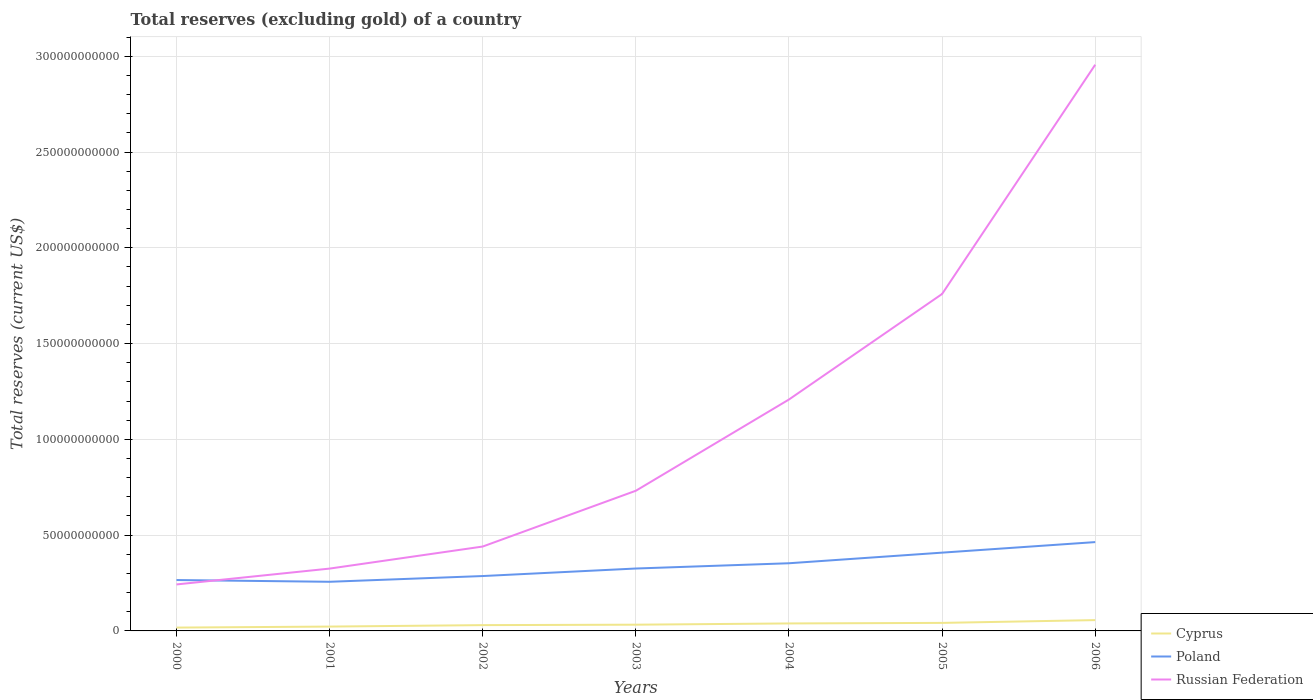Is the number of lines equal to the number of legend labels?
Give a very brief answer. Yes. Across all years, what is the maximum total reserves (excluding gold) in Russian Federation?
Your answer should be very brief. 2.43e+1. In which year was the total reserves (excluding gold) in Cyprus maximum?
Provide a succinct answer. 2000. What is the total total reserves (excluding gold) in Cyprus in the graph?
Provide a succinct answer. -1.92e+09. What is the difference between the highest and the second highest total reserves (excluding gold) in Russian Federation?
Your answer should be very brief. 2.71e+11. How many lines are there?
Make the answer very short. 3. What is the difference between two consecutive major ticks on the Y-axis?
Your answer should be compact. 5.00e+1. Are the values on the major ticks of Y-axis written in scientific E-notation?
Your response must be concise. No. Does the graph contain any zero values?
Provide a short and direct response. No. How many legend labels are there?
Provide a succinct answer. 3. How are the legend labels stacked?
Your response must be concise. Vertical. What is the title of the graph?
Your response must be concise. Total reserves (excluding gold) of a country. Does "Jordan" appear as one of the legend labels in the graph?
Your answer should be very brief. No. What is the label or title of the Y-axis?
Your answer should be very brief. Total reserves (current US$). What is the Total reserves (current US$) of Cyprus in 2000?
Make the answer very short. 1.74e+09. What is the Total reserves (current US$) of Poland in 2000?
Offer a terse response. 2.66e+1. What is the Total reserves (current US$) in Russian Federation in 2000?
Your answer should be compact. 2.43e+1. What is the Total reserves (current US$) of Cyprus in 2001?
Offer a terse response. 2.27e+09. What is the Total reserves (current US$) of Poland in 2001?
Your answer should be compact. 2.56e+1. What is the Total reserves (current US$) of Russian Federation in 2001?
Keep it short and to the point. 3.25e+1. What is the Total reserves (current US$) in Cyprus in 2002?
Offer a very short reply. 3.02e+09. What is the Total reserves (current US$) in Poland in 2002?
Your answer should be compact. 2.86e+1. What is the Total reserves (current US$) of Russian Federation in 2002?
Your answer should be very brief. 4.41e+1. What is the Total reserves (current US$) in Cyprus in 2003?
Ensure brevity in your answer.  3.26e+09. What is the Total reserves (current US$) of Poland in 2003?
Provide a succinct answer. 3.26e+1. What is the Total reserves (current US$) in Russian Federation in 2003?
Offer a terse response. 7.32e+1. What is the Total reserves (current US$) in Cyprus in 2004?
Your response must be concise. 3.91e+09. What is the Total reserves (current US$) of Poland in 2004?
Ensure brevity in your answer.  3.53e+1. What is the Total reserves (current US$) in Russian Federation in 2004?
Offer a terse response. 1.21e+11. What is the Total reserves (current US$) of Cyprus in 2005?
Provide a short and direct response. 4.19e+09. What is the Total reserves (current US$) in Poland in 2005?
Provide a short and direct response. 4.09e+1. What is the Total reserves (current US$) of Russian Federation in 2005?
Provide a short and direct response. 1.76e+11. What is the Total reserves (current US$) of Cyprus in 2006?
Your answer should be compact. 5.65e+09. What is the Total reserves (current US$) of Poland in 2006?
Offer a very short reply. 4.64e+1. What is the Total reserves (current US$) of Russian Federation in 2006?
Your response must be concise. 2.96e+11. Across all years, what is the maximum Total reserves (current US$) in Cyprus?
Offer a very short reply. 5.65e+09. Across all years, what is the maximum Total reserves (current US$) in Poland?
Provide a short and direct response. 4.64e+1. Across all years, what is the maximum Total reserves (current US$) in Russian Federation?
Your answer should be compact. 2.96e+11. Across all years, what is the minimum Total reserves (current US$) of Cyprus?
Give a very brief answer. 1.74e+09. Across all years, what is the minimum Total reserves (current US$) in Poland?
Offer a very short reply. 2.56e+1. Across all years, what is the minimum Total reserves (current US$) in Russian Federation?
Make the answer very short. 2.43e+1. What is the total Total reserves (current US$) in Cyprus in the graph?
Make the answer very short. 2.40e+1. What is the total Total reserves (current US$) in Poland in the graph?
Your answer should be very brief. 2.36e+11. What is the total Total reserves (current US$) in Russian Federation in the graph?
Give a very brief answer. 7.66e+11. What is the difference between the Total reserves (current US$) of Cyprus in 2000 and that in 2001?
Make the answer very short. -5.27e+08. What is the difference between the Total reserves (current US$) in Poland in 2000 and that in 2001?
Give a very brief answer. 9.14e+08. What is the difference between the Total reserves (current US$) of Russian Federation in 2000 and that in 2001?
Your answer should be very brief. -8.28e+09. What is the difference between the Total reserves (current US$) in Cyprus in 2000 and that in 2002?
Your response must be concise. -1.28e+09. What is the difference between the Total reserves (current US$) of Poland in 2000 and that in 2002?
Your response must be concise. -2.09e+09. What is the difference between the Total reserves (current US$) in Russian Federation in 2000 and that in 2002?
Give a very brief answer. -1.98e+1. What is the difference between the Total reserves (current US$) in Cyprus in 2000 and that in 2003?
Your answer should be compact. -1.52e+09. What is the difference between the Total reserves (current US$) of Poland in 2000 and that in 2003?
Give a very brief answer. -6.02e+09. What is the difference between the Total reserves (current US$) in Russian Federation in 2000 and that in 2003?
Provide a short and direct response. -4.89e+1. What is the difference between the Total reserves (current US$) in Cyprus in 2000 and that in 2004?
Your answer should be compact. -2.17e+09. What is the difference between the Total reserves (current US$) in Poland in 2000 and that in 2004?
Make the answer very short. -8.76e+09. What is the difference between the Total reserves (current US$) in Russian Federation in 2000 and that in 2004?
Your response must be concise. -9.65e+1. What is the difference between the Total reserves (current US$) of Cyprus in 2000 and that in 2005?
Your answer should be compact. -2.45e+09. What is the difference between the Total reserves (current US$) of Poland in 2000 and that in 2005?
Offer a very short reply. -1.43e+1. What is the difference between the Total reserves (current US$) of Russian Federation in 2000 and that in 2005?
Your answer should be compact. -1.52e+11. What is the difference between the Total reserves (current US$) of Cyprus in 2000 and that in 2006?
Provide a short and direct response. -3.91e+09. What is the difference between the Total reserves (current US$) in Poland in 2000 and that in 2006?
Your answer should be compact. -1.98e+1. What is the difference between the Total reserves (current US$) of Russian Federation in 2000 and that in 2006?
Make the answer very short. -2.71e+11. What is the difference between the Total reserves (current US$) in Cyprus in 2001 and that in 2002?
Your answer should be compact. -7.54e+08. What is the difference between the Total reserves (current US$) in Poland in 2001 and that in 2002?
Your answer should be very brief. -3.00e+09. What is the difference between the Total reserves (current US$) in Russian Federation in 2001 and that in 2002?
Your answer should be very brief. -1.15e+1. What is the difference between the Total reserves (current US$) in Cyprus in 2001 and that in 2003?
Your response must be concise. -9.89e+08. What is the difference between the Total reserves (current US$) of Poland in 2001 and that in 2003?
Give a very brief answer. -6.93e+09. What is the difference between the Total reserves (current US$) of Russian Federation in 2001 and that in 2003?
Give a very brief answer. -4.06e+1. What is the difference between the Total reserves (current US$) in Cyprus in 2001 and that in 2004?
Your answer should be very brief. -1.64e+09. What is the difference between the Total reserves (current US$) in Poland in 2001 and that in 2004?
Provide a succinct answer. -9.68e+09. What is the difference between the Total reserves (current US$) of Russian Federation in 2001 and that in 2004?
Your answer should be compact. -8.83e+1. What is the difference between the Total reserves (current US$) of Cyprus in 2001 and that in 2005?
Offer a very short reply. -1.92e+09. What is the difference between the Total reserves (current US$) in Poland in 2001 and that in 2005?
Your answer should be very brief. -1.52e+1. What is the difference between the Total reserves (current US$) in Russian Federation in 2001 and that in 2005?
Provide a short and direct response. -1.43e+11. What is the difference between the Total reserves (current US$) of Cyprus in 2001 and that in 2006?
Keep it short and to the point. -3.38e+09. What is the difference between the Total reserves (current US$) in Poland in 2001 and that in 2006?
Offer a terse response. -2.07e+1. What is the difference between the Total reserves (current US$) of Russian Federation in 2001 and that in 2006?
Keep it short and to the point. -2.63e+11. What is the difference between the Total reserves (current US$) in Cyprus in 2002 and that in 2003?
Offer a very short reply. -2.35e+08. What is the difference between the Total reserves (current US$) in Poland in 2002 and that in 2003?
Your answer should be very brief. -3.93e+09. What is the difference between the Total reserves (current US$) in Russian Federation in 2002 and that in 2003?
Your answer should be very brief. -2.91e+1. What is the difference between the Total reserves (current US$) of Cyprus in 2002 and that in 2004?
Your response must be concise. -8.88e+08. What is the difference between the Total reserves (current US$) in Poland in 2002 and that in 2004?
Make the answer very short. -6.67e+09. What is the difference between the Total reserves (current US$) in Russian Federation in 2002 and that in 2004?
Make the answer very short. -7.68e+1. What is the difference between the Total reserves (current US$) in Cyprus in 2002 and that in 2005?
Provide a succinct answer. -1.17e+09. What is the difference between the Total reserves (current US$) in Poland in 2002 and that in 2005?
Give a very brief answer. -1.22e+1. What is the difference between the Total reserves (current US$) of Russian Federation in 2002 and that in 2005?
Offer a very short reply. -1.32e+11. What is the difference between the Total reserves (current US$) of Cyprus in 2002 and that in 2006?
Offer a terse response. -2.62e+09. What is the difference between the Total reserves (current US$) of Poland in 2002 and that in 2006?
Ensure brevity in your answer.  -1.77e+1. What is the difference between the Total reserves (current US$) of Russian Federation in 2002 and that in 2006?
Provide a succinct answer. -2.52e+11. What is the difference between the Total reserves (current US$) in Cyprus in 2003 and that in 2004?
Offer a very short reply. -6.53e+08. What is the difference between the Total reserves (current US$) in Poland in 2003 and that in 2004?
Provide a succinct answer. -2.74e+09. What is the difference between the Total reserves (current US$) in Russian Federation in 2003 and that in 2004?
Provide a short and direct response. -4.76e+1. What is the difference between the Total reserves (current US$) in Cyprus in 2003 and that in 2005?
Provide a short and direct response. -9.34e+08. What is the difference between the Total reserves (current US$) in Poland in 2003 and that in 2005?
Your answer should be compact. -8.28e+09. What is the difference between the Total reserves (current US$) in Russian Federation in 2003 and that in 2005?
Give a very brief answer. -1.03e+11. What is the difference between the Total reserves (current US$) in Cyprus in 2003 and that in 2006?
Provide a short and direct response. -2.39e+09. What is the difference between the Total reserves (current US$) in Poland in 2003 and that in 2006?
Keep it short and to the point. -1.38e+1. What is the difference between the Total reserves (current US$) of Russian Federation in 2003 and that in 2006?
Give a very brief answer. -2.22e+11. What is the difference between the Total reserves (current US$) of Cyprus in 2004 and that in 2005?
Ensure brevity in your answer.  -2.81e+08. What is the difference between the Total reserves (current US$) of Poland in 2004 and that in 2005?
Offer a terse response. -5.54e+09. What is the difference between the Total reserves (current US$) of Russian Federation in 2004 and that in 2005?
Your response must be concise. -5.51e+1. What is the difference between the Total reserves (current US$) of Cyprus in 2004 and that in 2006?
Make the answer very short. -1.74e+09. What is the difference between the Total reserves (current US$) of Poland in 2004 and that in 2006?
Your response must be concise. -1.10e+1. What is the difference between the Total reserves (current US$) in Russian Federation in 2004 and that in 2006?
Your answer should be very brief. -1.75e+11. What is the difference between the Total reserves (current US$) in Cyprus in 2005 and that in 2006?
Offer a very short reply. -1.46e+09. What is the difference between the Total reserves (current US$) in Poland in 2005 and that in 2006?
Keep it short and to the point. -5.51e+09. What is the difference between the Total reserves (current US$) in Russian Federation in 2005 and that in 2006?
Your answer should be compact. -1.20e+11. What is the difference between the Total reserves (current US$) in Cyprus in 2000 and the Total reserves (current US$) in Poland in 2001?
Offer a terse response. -2.39e+1. What is the difference between the Total reserves (current US$) of Cyprus in 2000 and the Total reserves (current US$) of Russian Federation in 2001?
Ensure brevity in your answer.  -3.08e+1. What is the difference between the Total reserves (current US$) in Poland in 2000 and the Total reserves (current US$) in Russian Federation in 2001?
Provide a short and direct response. -5.98e+09. What is the difference between the Total reserves (current US$) in Cyprus in 2000 and the Total reserves (current US$) in Poland in 2002?
Provide a succinct answer. -2.69e+1. What is the difference between the Total reserves (current US$) of Cyprus in 2000 and the Total reserves (current US$) of Russian Federation in 2002?
Your answer should be compact. -4.23e+1. What is the difference between the Total reserves (current US$) in Poland in 2000 and the Total reserves (current US$) in Russian Federation in 2002?
Provide a succinct answer. -1.75e+1. What is the difference between the Total reserves (current US$) in Cyprus in 2000 and the Total reserves (current US$) in Poland in 2003?
Offer a very short reply. -3.08e+1. What is the difference between the Total reserves (current US$) of Cyprus in 2000 and the Total reserves (current US$) of Russian Federation in 2003?
Provide a short and direct response. -7.14e+1. What is the difference between the Total reserves (current US$) in Poland in 2000 and the Total reserves (current US$) in Russian Federation in 2003?
Your answer should be very brief. -4.66e+1. What is the difference between the Total reserves (current US$) of Cyprus in 2000 and the Total reserves (current US$) of Poland in 2004?
Provide a succinct answer. -3.36e+1. What is the difference between the Total reserves (current US$) in Cyprus in 2000 and the Total reserves (current US$) in Russian Federation in 2004?
Provide a short and direct response. -1.19e+11. What is the difference between the Total reserves (current US$) in Poland in 2000 and the Total reserves (current US$) in Russian Federation in 2004?
Your answer should be compact. -9.42e+1. What is the difference between the Total reserves (current US$) of Cyprus in 2000 and the Total reserves (current US$) of Poland in 2005?
Provide a short and direct response. -3.91e+1. What is the difference between the Total reserves (current US$) of Cyprus in 2000 and the Total reserves (current US$) of Russian Federation in 2005?
Offer a very short reply. -1.74e+11. What is the difference between the Total reserves (current US$) in Poland in 2000 and the Total reserves (current US$) in Russian Federation in 2005?
Keep it short and to the point. -1.49e+11. What is the difference between the Total reserves (current US$) of Cyprus in 2000 and the Total reserves (current US$) of Poland in 2006?
Offer a terse response. -4.46e+1. What is the difference between the Total reserves (current US$) in Cyprus in 2000 and the Total reserves (current US$) in Russian Federation in 2006?
Your response must be concise. -2.94e+11. What is the difference between the Total reserves (current US$) of Poland in 2000 and the Total reserves (current US$) of Russian Federation in 2006?
Ensure brevity in your answer.  -2.69e+11. What is the difference between the Total reserves (current US$) in Cyprus in 2001 and the Total reserves (current US$) in Poland in 2002?
Ensure brevity in your answer.  -2.64e+1. What is the difference between the Total reserves (current US$) of Cyprus in 2001 and the Total reserves (current US$) of Russian Federation in 2002?
Provide a succinct answer. -4.18e+1. What is the difference between the Total reserves (current US$) in Poland in 2001 and the Total reserves (current US$) in Russian Federation in 2002?
Provide a short and direct response. -1.84e+1. What is the difference between the Total reserves (current US$) of Cyprus in 2001 and the Total reserves (current US$) of Poland in 2003?
Your answer should be compact. -3.03e+1. What is the difference between the Total reserves (current US$) of Cyprus in 2001 and the Total reserves (current US$) of Russian Federation in 2003?
Provide a succinct answer. -7.09e+1. What is the difference between the Total reserves (current US$) of Poland in 2001 and the Total reserves (current US$) of Russian Federation in 2003?
Your answer should be compact. -4.75e+1. What is the difference between the Total reserves (current US$) in Cyprus in 2001 and the Total reserves (current US$) in Poland in 2004?
Offer a very short reply. -3.31e+1. What is the difference between the Total reserves (current US$) in Cyprus in 2001 and the Total reserves (current US$) in Russian Federation in 2004?
Ensure brevity in your answer.  -1.19e+11. What is the difference between the Total reserves (current US$) of Poland in 2001 and the Total reserves (current US$) of Russian Federation in 2004?
Your answer should be compact. -9.52e+1. What is the difference between the Total reserves (current US$) of Cyprus in 2001 and the Total reserves (current US$) of Poland in 2005?
Provide a succinct answer. -3.86e+1. What is the difference between the Total reserves (current US$) of Cyprus in 2001 and the Total reserves (current US$) of Russian Federation in 2005?
Make the answer very short. -1.74e+11. What is the difference between the Total reserves (current US$) of Poland in 2001 and the Total reserves (current US$) of Russian Federation in 2005?
Make the answer very short. -1.50e+11. What is the difference between the Total reserves (current US$) in Cyprus in 2001 and the Total reserves (current US$) in Poland in 2006?
Provide a succinct answer. -4.41e+1. What is the difference between the Total reserves (current US$) of Cyprus in 2001 and the Total reserves (current US$) of Russian Federation in 2006?
Make the answer very short. -2.93e+11. What is the difference between the Total reserves (current US$) of Poland in 2001 and the Total reserves (current US$) of Russian Federation in 2006?
Provide a succinct answer. -2.70e+11. What is the difference between the Total reserves (current US$) in Cyprus in 2002 and the Total reserves (current US$) in Poland in 2003?
Ensure brevity in your answer.  -2.96e+1. What is the difference between the Total reserves (current US$) of Cyprus in 2002 and the Total reserves (current US$) of Russian Federation in 2003?
Give a very brief answer. -7.02e+1. What is the difference between the Total reserves (current US$) in Poland in 2002 and the Total reserves (current US$) in Russian Federation in 2003?
Offer a very short reply. -4.45e+1. What is the difference between the Total reserves (current US$) in Cyprus in 2002 and the Total reserves (current US$) in Poland in 2004?
Offer a very short reply. -3.23e+1. What is the difference between the Total reserves (current US$) in Cyprus in 2002 and the Total reserves (current US$) in Russian Federation in 2004?
Keep it short and to the point. -1.18e+11. What is the difference between the Total reserves (current US$) of Poland in 2002 and the Total reserves (current US$) of Russian Federation in 2004?
Your answer should be compact. -9.22e+1. What is the difference between the Total reserves (current US$) of Cyprus in 2002 and the Total reserves (current US$) of Poland in 2005?
Ensure brevity in your answer.  -3.78e+1. What is the difference between the Total reserves (current US$) in Cyprus in 2002 and the Total reserves (current US$) in Russian Federation in 2005?
Make the answer very short. -1.73e+11. What is the difference between the Total reserves (current US$) in Poland in 2002 and the Total reserves (current US$) in Russian Federation in 2005?
Keep it short and to the point. -1.47e+11. What is the difference between the Total reserves (current US$) in Cyprus in 2002 and the Total reserves (current US$) in Poland in 2006?
Make the answer very short. -4.33e+1. What is the difference between the Total reserves (current US$) of Cyprus in 2002 and the Total reserves (current US$) of Russian Federation in 2006?
Your answer should be compact. -2.93e+11. What is the difference between the Total reserves (current US$) of Poland in 2002 and the Total reserves (current US$) of Russian Federation in 2006?
Your response must be concise. -2.67e+11. What is the difference between the Total reserves (current US$) in Cyprus in 2003 and the Total reserves (current US$) in Poland in 2004?
Offer a terse response. -3.21e+1. What is the difference between the Total reserves (current US$) of Cyprus in 2003 and the Total reserves (current US$) of Russian Federation in 2004?
Offer a very short reply. -1.18e+11. What is the difference between the Total reserves (current US$) in Poland in 2003 and the Total reserves (current US$) in Russian Federation in 2004?
Provide a succinct answer. -8.82e+1. What is the difference between the Total reserves (current US$) in Cyprus in 2003 and the Total reserves (current US$) in Poland in 2005?
Provide a succinct answer. -3.76e+1. What is the difference between the Total reserves (current US$) in Cyprus in 2003 and the Total reserves (current US$) in Russian Federation in 2005?
Make the answer very short. -1.73e+11. What is the difference between the Total reserves (current US$) in Poland in 2003 and the Total reserves (current US$) in Russian Federation in 2005?
Offer a very short reply. -1.43e+11. What is the difference between the Total reserves (current US$) in Cyprus in 2003 and the Total reserves (current US$) in Poland in 2006?
Your response must be concise. -4.31e+1. What is the difference between the Total reserves (current US$) of Cyprus in 2003 and the Total reserves (current US$) of Russian Federation in 2006?
Your response must be concise. -2.92e+11. What is the difference between the Total reserves (current US$) in Poland in 2003 and the Total reserves (current US$) in Russian Federation in 2006?
Keep it short and to the point. -2.63e+11. What is the difference between the Total reserves (current US$) of Cyprus in 2004 and the Total reserves (current US$) of Poland in 2005?
Keep it short and to the point. -3.70e+1. What is the difference between the Total reserves (current US$) in Cyprus in 2004 and the Total reserves (current US$) in Russian Federation in 2005?
Offer a terse response. -1.72e+11. What is the difference between the Total reserves (current US$) in Poland in 2004 and the Total reserves (current US$) in Russian Federation in 2005?
Offer a terse response. -1.41e+11. What is the difference between the Total reserves (current US$) of Cyprus in 2004 and the Total reserves (current US$) of Poland in 2006?
Your answer should be very brief. -4.25e+1. What is the difference between the Total reserves (current US$) in Cyprus in 2004 and the Total reserves (current US$) in Russian Federation in 2006?
Provide a short and direct response. -2.92e+11. What is the difference between the Total reserves (current US$) of Poland in 2004 and the Total reserves (current US$) of Russian Federation in 2006?
Give a very brief answer. -2.60e+11. What is the difference between the Total reserves (current US$) of Cyprus in 2005 and the Total reserves (current US$) of Poland in 2006?
Provide a short and direct response. -4.22e+1. What is the difference between the Total reserves (current US$) in Cyprus in 2005 and the Total reserves (current US$) in Russian Federation in 2006?
Give a very brief answer. -2.91e+11. What is the difference between the Total reserves (current US$) of Poland in 2005 and the Total reserves (current US$) of Russian Federation in 2006?
Your response must be concise. -2.55e+11. What is the average Total reserves (current US$) in Cyprus per year?
Provide a succinct answer. 3.43e+09. What is the average Total reserves (current US$) in Poland per year?
Your answer should be very brief. 3.37e+1. What is the average Total reserves (current US$) of Russian Federation per year?
Offer a very short reply. 1.09e+11. In the year 2000, what is the difference between the Total reserves (current US$) in Cyprus and Total reserves (current US$) in Poland?
Your answer should be very brief. -2.48e+1. In the year 2000, what is the difference between the Total reserves (current US$) in Cyprus and Total reserves (current US$) in Russian Federation?
Your answer should be compact. -2.25e+1. In the year 2000, what is the difference between the Total reserves (current US$) of Poland and Total reserves (current US$) of Russian Federation?
Keep it short and to the point. 2.30e+09. In the year 2001, what is the difference between the Total reserves (current US$) of Cyprus and Total reserves (current US$) of Poland?
Ensure brevity in your answer.  -2.34e+1. In the year 2001, what is the difference between the Total reserves (current US$) in Cyprus and Total reserves (current US$) in Russian Federation?
Your response must be concise. -3.03e+1. In the year 2001, what is the difference between the Total reserves (current US$) in Poland and Total reserves (current US$) in Russian Federation?
Keep it short and to the point. -6.89e+09. In the year 2002, what is the difference between the Total reserves (current US$) of Cyprus and Total reserves (current US$) of Poland?
Your answer should be compact. -2.56e+1. In the year 2002, what is the difference between the Total reserves (current US$) of Cyprus and Total reserves (current US$) of Russian Federation?
Your answer should be compact. -4.10e+1. In the year 2002, what is the difference between the Total reserves (current US$) in Poland and Total reserves (current US$) in Russian Federation?
Offer a terse response. -1.54e+1. In the year 2003, what is the difference between the Total reserves (current US$) of Cyprus and Total reserves (current US$) of Poland?
Keep it short and to the point. -2.93e+1. In the year 2003, what is the difference between the Total reserves (current US$) in Cyprus and Total reserves (current US$) in Russian Federation?
Offer a terse response. -6.99e+1. In the year 2003, what is the difference between the Total reserves (current US$) in Poland and Total reserves (current US$) in Russian Federation?
Keep it short and to the point. -4.06e+1. In the year 2004, what is the difference between the Total reserves (current US$) in Cyprus and Total reserves (current US$) in Poland?
Make the answer very short. -3.14e+1. In the year 2004, what is the difference between the Total reserves (current US$) in Cyprus and Total reserves (current US$) in Russian Federation?
Provide a succinct answer. -1.17e+11. In the year 2004, what is the difference between the Total reserves (current US$) in Poland and Total reserves (current US$) in Russian Federation?
Your answer should be compact. -8.55e+1. In the year 2005, what is the difference between the Total reserves (current US$) of Cyprus and Total reserves (current US$) of Poland?
Offer a terse response. -3.67e+1. In the year 2005, what is the difference between the Total reserves (current US$) in Cyprus and Total reserves (current US$) in Russian Federation?
Make the answer very short. -1.72e+11. In the year 2005, what is the difference between the Total reserves (current US$) in Poland and Total reserves (current US$) in Russian Federation?
Keep it short and to the point. -1.35e+11. In the year 2006, what is the difference between the Total reserves (current US$) in Cyprus and Total reserves (current US$) in Poland?
Provide a succinct answer. -4.07e+1. In the year 2006, what is the difference between the Total reserves (current US$) in Cyprus and Total reserves (current US$) in Russian Federation?
Your response must be concise. -2.90e+11. In the year 2006, what is the difference between the Total reserves (current US$) of Poland and Total reserves (current US$) of Russian Federation?
Ensure brevity in your answer.  -2.49e+11. What is the ratio of the Total reserves (current US$) of Cyprus in 2000 to that in 2001?
Your answer should be very brief. 0.77. What is the ratio of the Total reserves (current US$) of Poland in 2000 to that in 2001?
Your answer should be compact. 1.04. What is the ratio of the Total reserves (current US$) of Russian Federation in 2000 to that in 2001?
Offer a very short reply. 0.75. What is the ratio of the Total reserves (current US$) of Cyprus in 2000 to that in 2002?
Provide a short and direct response. 0.58. What is the ratio of the Total reserves (current US$) in Poland in 2000 to that in 2002?
Your answer should be compact. 0.93. What is the ratio of the Total reserves (current US$) of Russian Federation in 2000 to that in 2002?
Provide a short and direct response. 0.55. What is the ratio of the Total reserves (current US$) of Cyprus in 2000 to that in 2003?
Your answer should be very brief. 0.53. What is the ratio of the Total reserves (current US$) in Poland in 2000 to that in 2003?
Make the answer very short. 0.82. What is the ratio of the Total reserves (current US$) in Russian Federation in 2000 to that in 2003?
Make the answer very short. 0.33. What is the ratio of the Total reserves (current US$) in Cyprus in 2000 to that in 2004?
Keep it short and to the point. 0.45. What is the ratio of the Total reserves (current US$) of Poland in 2000 to that in 2004?
Make the answer very short. 0.75. What is the ratio of the Total reserves (current US$) in Russian Federation in 2000 to that in 2004?
Your answer should be very brief. 0.2. What is the ratio of the Total reserves (current US$) in Cyprus in 2000 to that in 2005?
Ensure brevity in your answer.  0.42. What is the ratio of the Total reserves (current US$) of Poland in 2000 to that in 2005?
Offer a terse response. 0.65. What is the ratio of the Total reserves (current US$) of Russian Federation in 2000 to that in 2005?
Offer a terse response. 0.14. What is the ratio of the Total reserves (current US$) in Cyprus in 2000 to that in 2006?
Offer a very short reply. 0.31. What is the ratio of the Total reserves (current US$) of Poland in 2000 to that in 2006?
Keep it short and to the point. 0.57. What is the ratio of the Total reserves (current US$) of Russian Federation in 2000 to that in 2006?
Provide a short and direct response. 0.08. What is the ratio of the Total reserves (current US$) of Cyprus in 2001 to that in 2002?
Provide a short and direct response. 0.75. What is the ratio of the Total reserves (current US$) of Poland in 2001 to that in 2002?
Your response must be concise. 0.9. What is the ratio of the Total reserves (current US$) in Russian Federation in 2001 to that in 2002?
Make the answer very short. 0.74. What is the ratio of the Total reserves (current US$) in Cyprus in 2001 to that in 2003?
Keep it short and to the point. 0.7. What is the ratio of the Total reserves (current US$) of Poland in 2001 to that in 2003?
Your answer should be compact. 0.79. What is the ratio of the Total reserves (current US$) in Russian Federation in 2001 to that in 2003?
Your response must be concise. 0.44. What is the ratio of the Total reserves (current US$) in Cyprus in 2001 to that in 2004?
Offer a terse response. 0.58. What is the ratio of the Total reserves (current US$) of Poland in 2001 to that in 2004?
Provide a succinct answer. 0.73. What is the ratio of the Total reserves (current US$) in Russian Federation in 2001 to that in 2004?
Ensure brevity in your answer.  0.27. What is the ratio of the Total reserves (current US$) in Cyprus in 2001 to that in 2005?
Provide a short and direct response. 0.54. What is the ratio of the Total reserves (current US$) of Poland in 2001 to that in 2005?
Your response must be concise. 0.63. What is the ratio of the Total reserves (current US$) in Russian Federation in 2001 to that in 2005?
Make the answer very short. 0.18. What is the ratio of the Total reserves (current US$) of Cyprus in 2001 to that in 2006?
Your answer should be compact. 0.4. What is the ratio of the Total reserves (current US$) in Poland in 2001 to that in 2006?
Your response must be concise. 0.55. What is the ratio of the Total reserves (current US$) of Russian Federation in 2001 to that in 2006?
Provide a succinct answer. 0.11. What is the ratio of the Total reserves (current US$) in Cyprus in 2002 to that in 2003?
Offer a very short reply. 0.93. What is the ratio of the Total reserves (current US$) of Poland in 2002 to that in 2003?
Give a very brief answer. 0.88. What is the ratio of the Total reserves (current US$) of Russian Federation in 2002 to that in 2003?
Keep it short and to the point. 0.6. What is the ratio of the Total reserves (current US$) of Cyprus in 2002 to that in 2004?
Make the answer very short. 0.77. What is the ratio of the Total reserves (current US$) of Poland in 2002 to that in 2004?
Provide a short and direct response. 0.81. What is the ratio of the Total reserves (current US$) in Russian Federation in 2002 to that in 2004?
Offer a terse response. 0.36. What is the ratio of the Total reserves (current US$) of Cyprus in 2002 to that in 2005?
Offer a very short reply. 0.72. What is the ratio of the Total reserves (current US$) of Poland in 2002 to that in 2005?
Keep it short and to the point. 0.7. What is the ratio of the Total reserves (current US$) of Russian Federation in 2002 to that in 2005?
Your response must be concise. 0.25. What is the ratio of the Total reserves (current US$) in Cyprus in 2002 to that in 2006?
Offer a terse response. 0.54. What is the ratio of the Total reserves (current US$) in Poland in 2002 to that in 2006?
Provide a succinct answer. 0.62. What is the ratio of the Total reserves (current US$) in Russian Federation in 2002 to that in 2006?
Offer a very short reply. 0.15. What is the ratio of the Total reserves (current US$) in Cyprus in 2003 to that in 2004?
Provide a short and direct response. 0.83. What is the ratio of the Total reserves (current US$) in Poland in 2003 to that in 2004?
Provide a short and direct response. 0.92. What is the ratio of the Total reserves (current US$) of Russian Federation in 2003 to that in 2004?
Make the answer very short. 0.61. What is the ratio of the Total reserves (current US$) of Cyprus in 2003 to that in 2005?
Your response must be concise. 0.78. What is the ratio of the Total reserves (current US$) in Poland in 2003 to that in 2005?
Offer a terse response. 0.8. What is the ratio of the Total reserves (current US$) of Russian Federation in 2003 to that in 2005?
Make the answer very short. 0.42. What is the ratio of the Total reserves (current US$) of Cyprus in 2003 to that in 2006?
Your answer should be compact. 0.58. What is the ratio of the Total reserves (current US$) in Poland in 2003 to that in 2006?
Ensure brevity in your answer.  0.7. What is the ratio of the Total reserves (current US$) in Russian Federation in 2003 to that in 2006?
Your response must be concise. 0.25. What is the ratio of the Total reserves (current US$) in Cyprus in 2004 to that in 2005?
Offer a terse response. 0.93. What is the ratio of the Total reserves (current US$) in Poland in 2004 to that in 2005?
Keep it short and to the point. 0.86. What is the ratio of the Total reserves (current US$) of Russian Federation in 2004 to that in 2005?
Provide a short and direct response. 0.69. What is the ratio of the Total reserves (current US$) in Cyprus in 2004 to that in 2006?
Ensure brevity in your answer.  0.69. What is the ratio of the Total reserves (current US$) in Poland in 2004 to that in 2006?
Your answer should be very brief. 0.76. What is the ratio of the Total reserves (current US$) of Russian Federation in 2004 to that in 2006?
Ensure brevity in your answer.  0.41. What is the ratio of the Total reserves (current US$) of Cyprus in 2005 to that in 2006?
Your response must be concise. 0.74. What is the ratio of the Total reserves (current US$) in Poland in 2005 to that in 2006?
Your answer should be very brief. 0.88. What is the ratio of the Total reserves (current US$) in Russian Federation in 2005 to that in 2006?
Give a very brief answer. 0.6. What is the difference between the highest and the second highest Total reserves (current US$) in Cyprus?
Your answer should be very brief. 1.46e+09. What is the difference between the highest and the second highest Total reserves (current US$) in Poland?
Keep it short and to the point. 5.51e+09. What is the difference between the highest and the second highest Total reserves (current US$) in Russian Federation?
Make the answer very short. 1.20e+11. What is the difference between the highest and the lowest Total reserves (current US$) of Cyprus?
Give a very brief answer. 3.91e+09. What is the difference between the highest and the lowest Total reserves (current US$) in Poland?
Your answer should be compact. 2.07e+1. What is the difference between the highest and the lowest Total reserves (current US$) in Russian Federation?
Your answer should be very brief. 2.71e+11. 